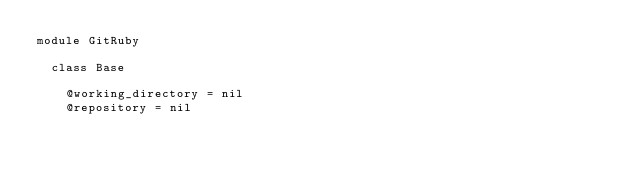<code> <loc_0><loc_0><loc_500><loc_500><_Ruby_>module GitRuby
  
  class Base

    @working_directory = nil
    @repository = nil</code> 